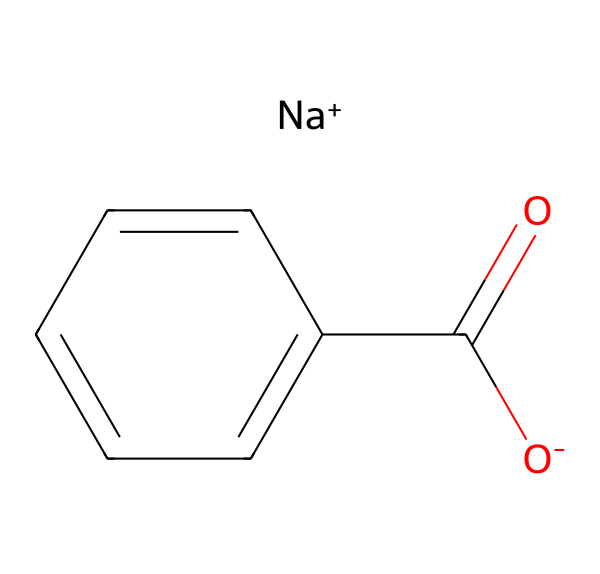What is the main functional group present in sodium benzoate? The structure contains a carboxylate group (the -COO^- portion), which is characteristic of carboxylic acids and their salts.
Answer: carboxylate How many carbon atoms are present in sodium benzoate? By examining the structure, there are seven carbon atoms: one in the carboxylate and six in the benzene ring.
Answer: seven What type of chemical is sodium benzoate? Sodium benzoate is a salt, specifically the sodium salt of benzoic acid, derived from its carboxylate form.
Answer: salt How many hydrogen atoms are there in sodium benzoate? The carboxylate part contributes one hydrogen (from the carbon) and the benzene has five hydrogens, but due to the substitution by the carboxylate, there are only four left in the ring. Thus, there are four hydrogen atoms total.
Answer: four What is the charge on the sodium in sodium benzoate? Sodium is noted with a positive charge (Na^+), indicating it is a cation in the compound.
Answer: positive What is the primary reason for using sodium benzoate as a preservative in ancient civilizations? Sodium benzoate has antimicrobial properties and inhibits the growth of mold, yeast, and some types of bacteria, making it effective for food preservation.
Answer: antimicrobial 